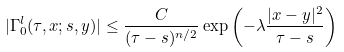Convert formula to latex. <formula><loc_0><loc_0><loc_500><loc_500>| \Gamma ^ { l } _ { 0 } ( \tau , x ; s , y ) | \leq \frac { C } { ( \tau - s ) ^ { n / 2 } } \exp \left ( - \lambda \frac { | x - y | ^ { 2 } } { \tau - s } \right )</formula> 